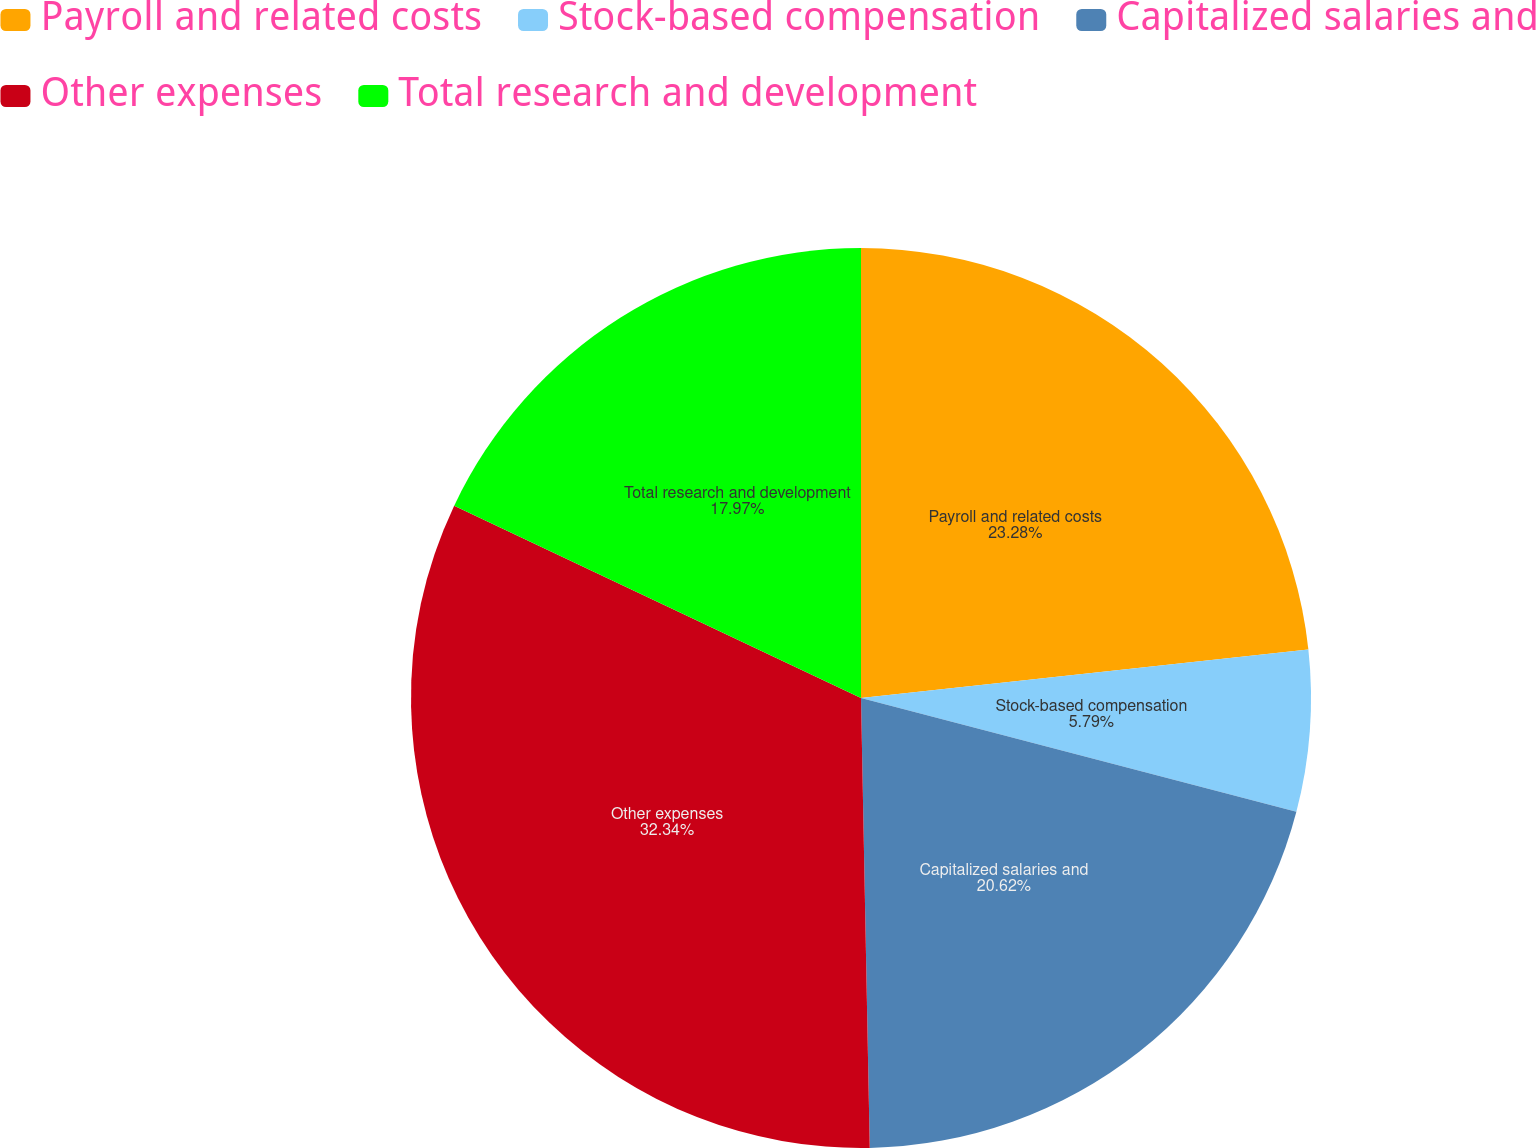Convert chart to OTSL. <chart><loc_0><loc_0><loc_500><loc_500><pie_chart><fcel>Payroll and related costs<fcel>Stock-based compensation<fcel>Capitalized salaries and<fcel>Other expenses<fcel>Total research and development<nl><fcel>23.28%<fcel>5.79%<fcel>20.62%<fcel>32.34%<fcel>17.97%<nl></chart> 